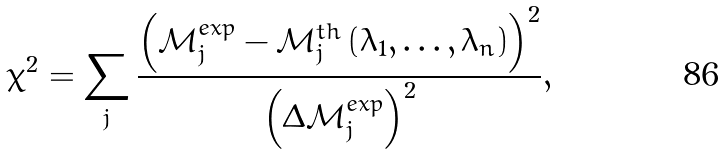Convert formula to latex. <formula><loc_0><loc_0><loc_500><loc_500>\chi ^ { 2 } = \sum _ { j } \frac { \left ( \mathcal { M } ^ { e x p } _ { j } - \mathcal { M } ^ { t h } _ { j } \left ( \lambda _ { 1 } , \dots , \lambda _ { n } \right ) \right ) ^ { 2 } } { \left ( \Delta \mathcal { M } ^ { e x p } _ { j } \right ) ^ { 2 } } ,</formula> 